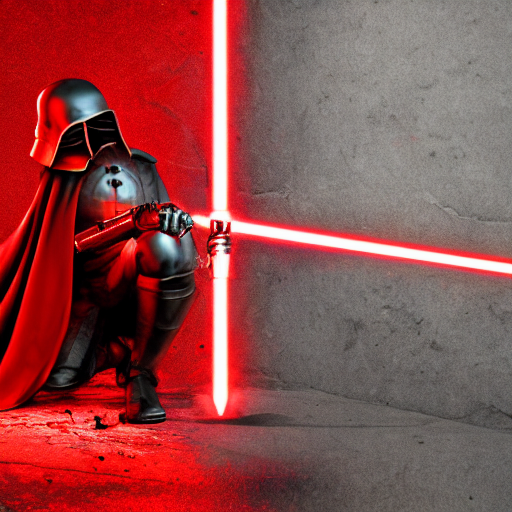Could the position of the character indicate anything about their intentions or state of mind? The character's kneeling position with a lightsaber at the ready could suggest preparation for battle, a moment of respect, or reflection. It's a posture that communicates readiness, focus, and a strong sense of purpose. 